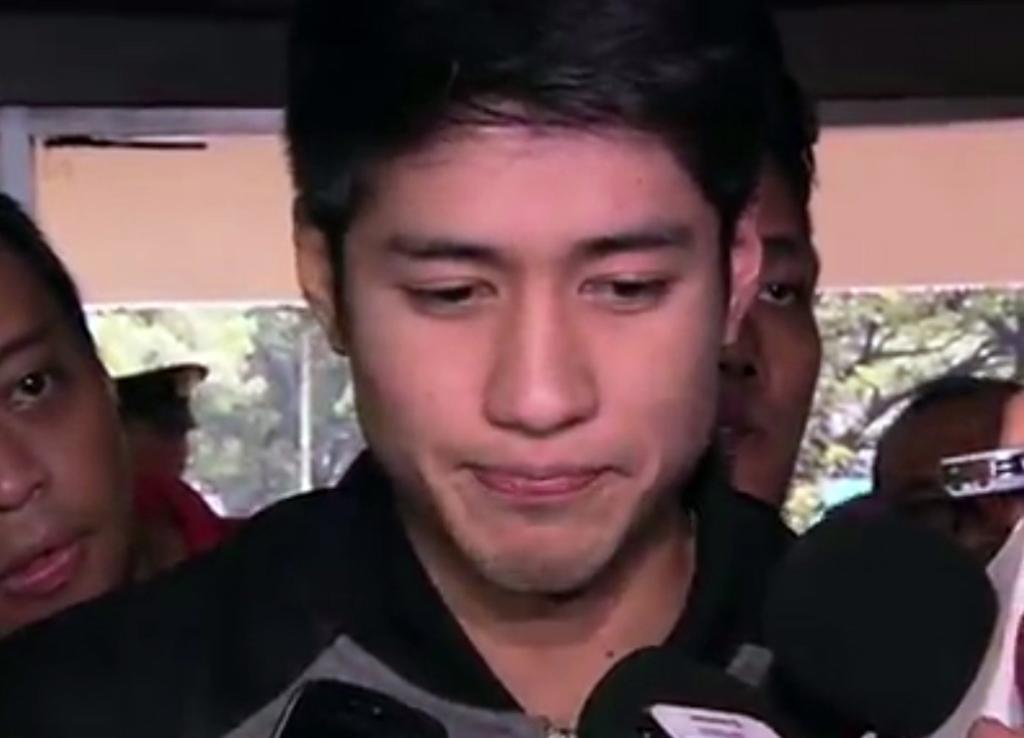Can you describe this image briefly? In this image, in the middle, we can see a man wearing a black color shirt. In the background, we can see a group of people and trees. 